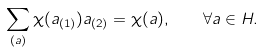Convert formula to latex. <formula><loc_0><loc_0><loc_500><loc_500>\sum _ { ( a ) } \chi ( a _ { ( 1 ) } ) a _ { ( 2 ) } = \chi ( a ) , \quad \forall a \in H .</formula> 